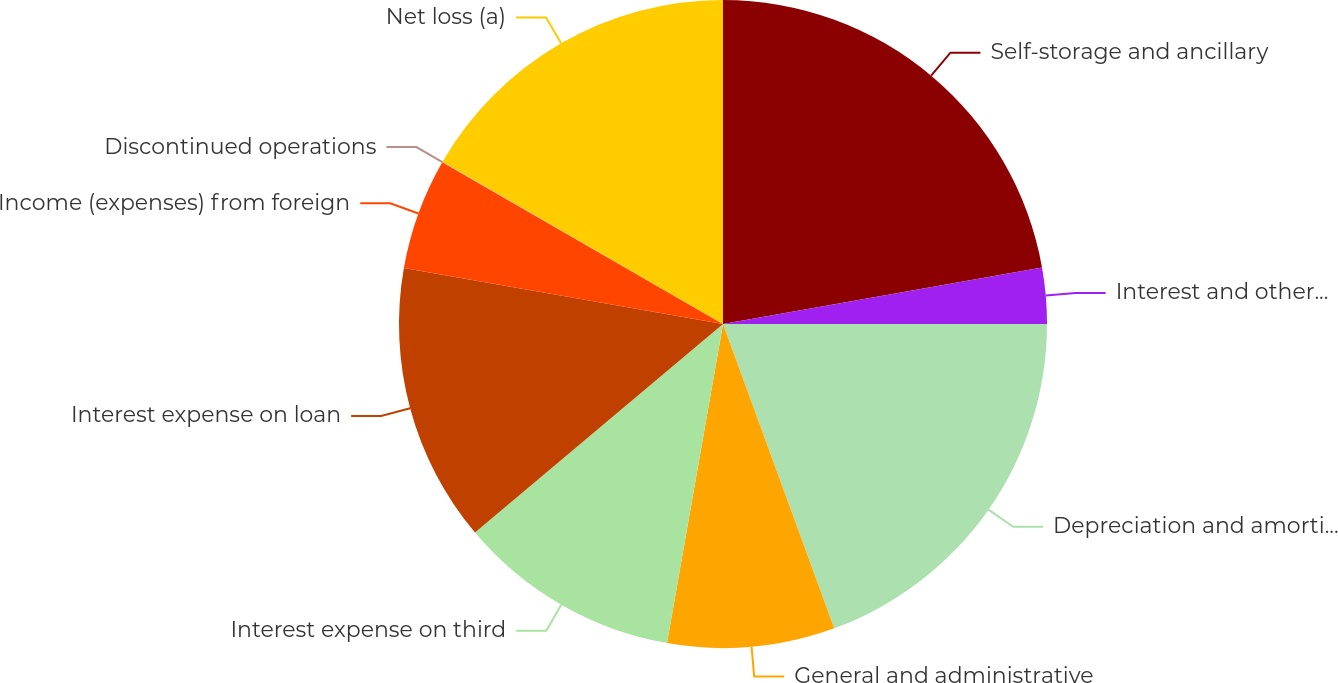<chart> <loc_0><loc_0><loc_500><loc_500><pie_chart><fcel>Self-storage and ancillary<fcel>Interest and other income<fcel>Depreciation and amortization<fcel>General and administrative<fcel>Interest expense on third<fcel>Interest expense on loan<fcel>Income (expenses) from foreign<fcel>Discontinued operations<fcel>Net loss (a)<nl><fcel>22.21%<fcel>2.79%<fcel>19.43%<fcel>8.34%<fcel>11.11%<fcel>13.89%<fcel>5.56%<fcel>0.02%<fcel>16.66%<nl></chart> 